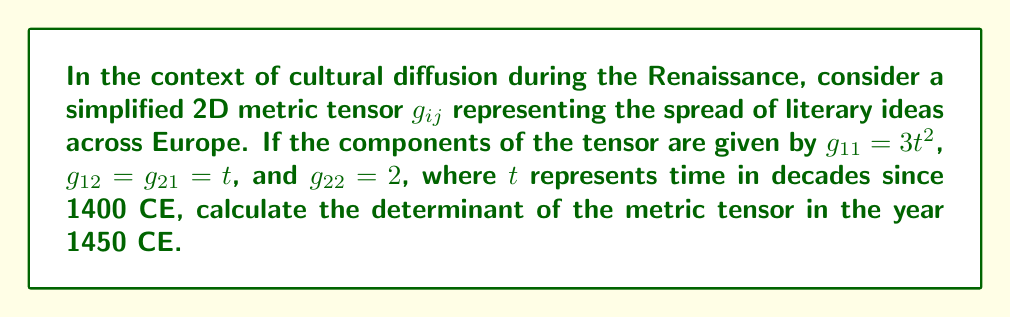Can you answer this question? To solve this problem, we'll follow these steps:

1) First, we need to identify the components of the metric tensor:
   $$g_{ij} = \begin{pmatrix}
   3t^2 & t \\
   t & 2
   \end{pmatrix}$$

2) The time $t$ is given in decades since 1400 CE. For the year 1450 CE:
   $t = (1450 - 1400) / 10 = 5$ decades

3) Now, we substitute $t = 5$ into our metric tensor:
   $$g_{ij} = \begin{pmatrix}
   3(5^2) & 5 \\
   5 & 2
   \end{pmatrix} = \begin{pmatrix}
   75 & 5 \\
   5 & 2
   \end{pmatrix}$$

4) To find the determinant of a 2x2 matrix, we use the formula:
   $\det(g_{ij}) = g_{11}g_{22} - g_{12}g_{21}$

5) Substituting our values:
   $\det(g_{ij}) = (75)(2) - (5)(5) = 150 - 25 = 125$

Therefore, the determinant of the metric tensor in 1450 CE is 125.
Answer: 125 